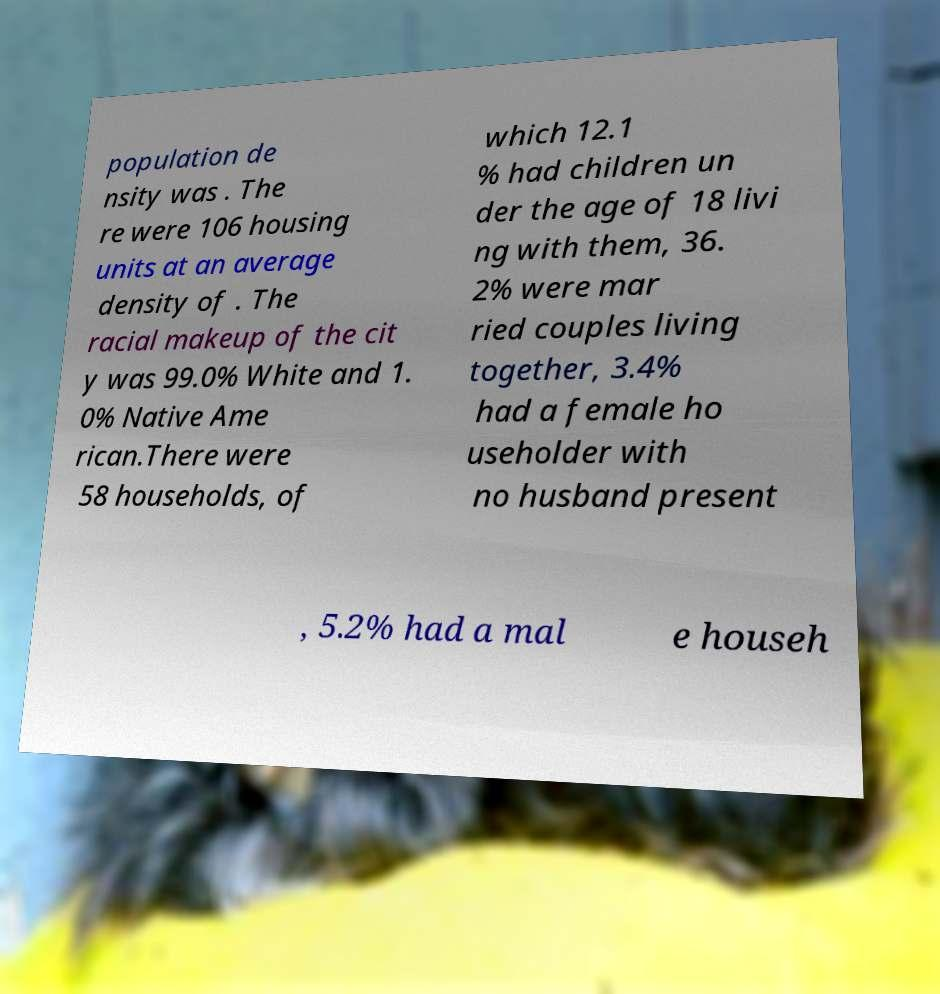Could you assist in decoding the text presented in this image and type it out clearly? population de nsity was . The re were 106 housing units at an average density of . The racial makeup of the cit y was 99.0% White and 1. 0% Native Ame rican.There were 58 households, of which 12.1 % had children un der the age of 18 livi ng with them, 36. 2% were mar ried couples living together, 3.4% had a female ho useholder with no husband present , 5.2% had a mal e househ 